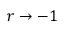<formula> <loc_0><loc_0><loc_500><loc_500>r \rightarrow - 1</formula> 